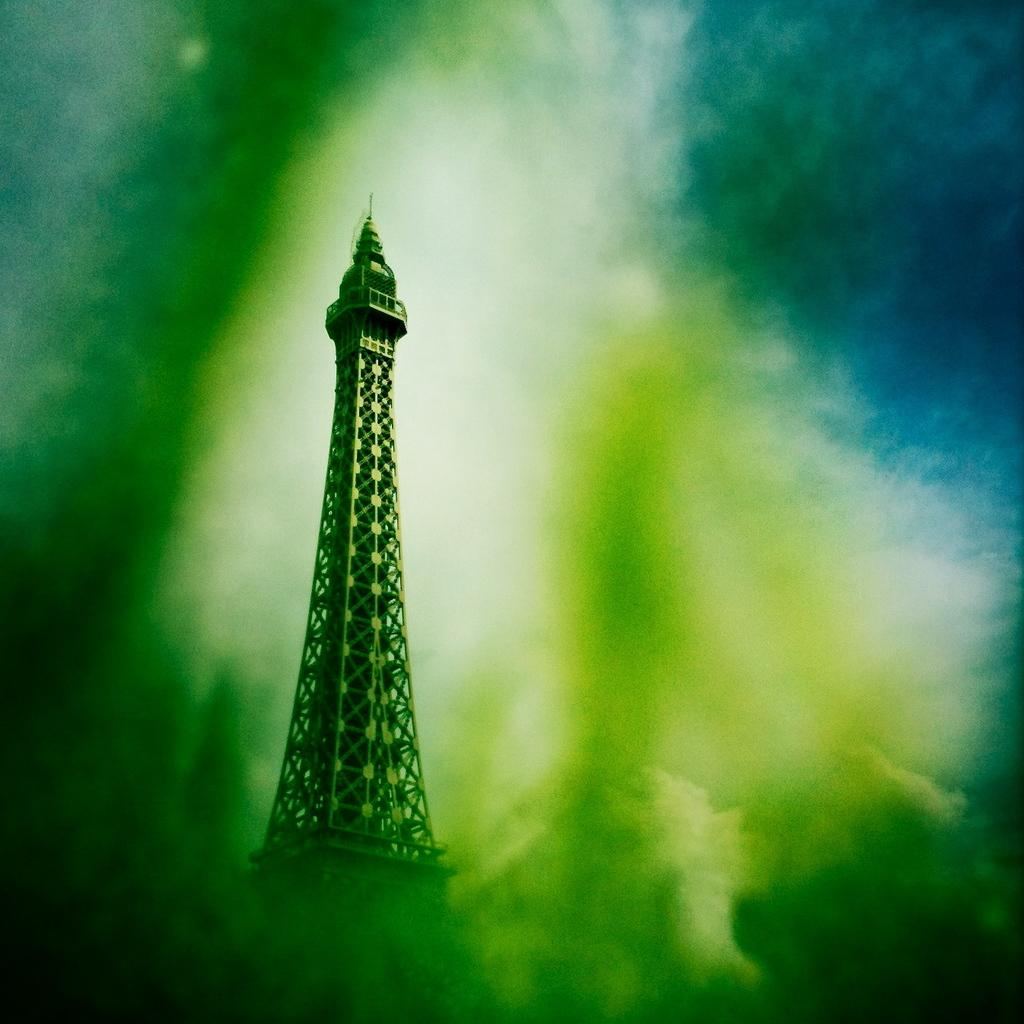What type of picture is present in the image? The image contains an edited picture. What colors are present in the edited picture? The edited picture has green, white, and blue colors. What structure can be seen in the image? There is a metal tower in the image. What part of the natural environment is visible in the image? The sky is visible in the image. Can you see a balloon floating in the sky in the image? There is no balloon present in the image; it only features an edited picture, a metal tower, and the sky. How many stitches are used to create the edited picture in the image? The edited picture is not created using stitches; it is a digital manipulation of the original image. 